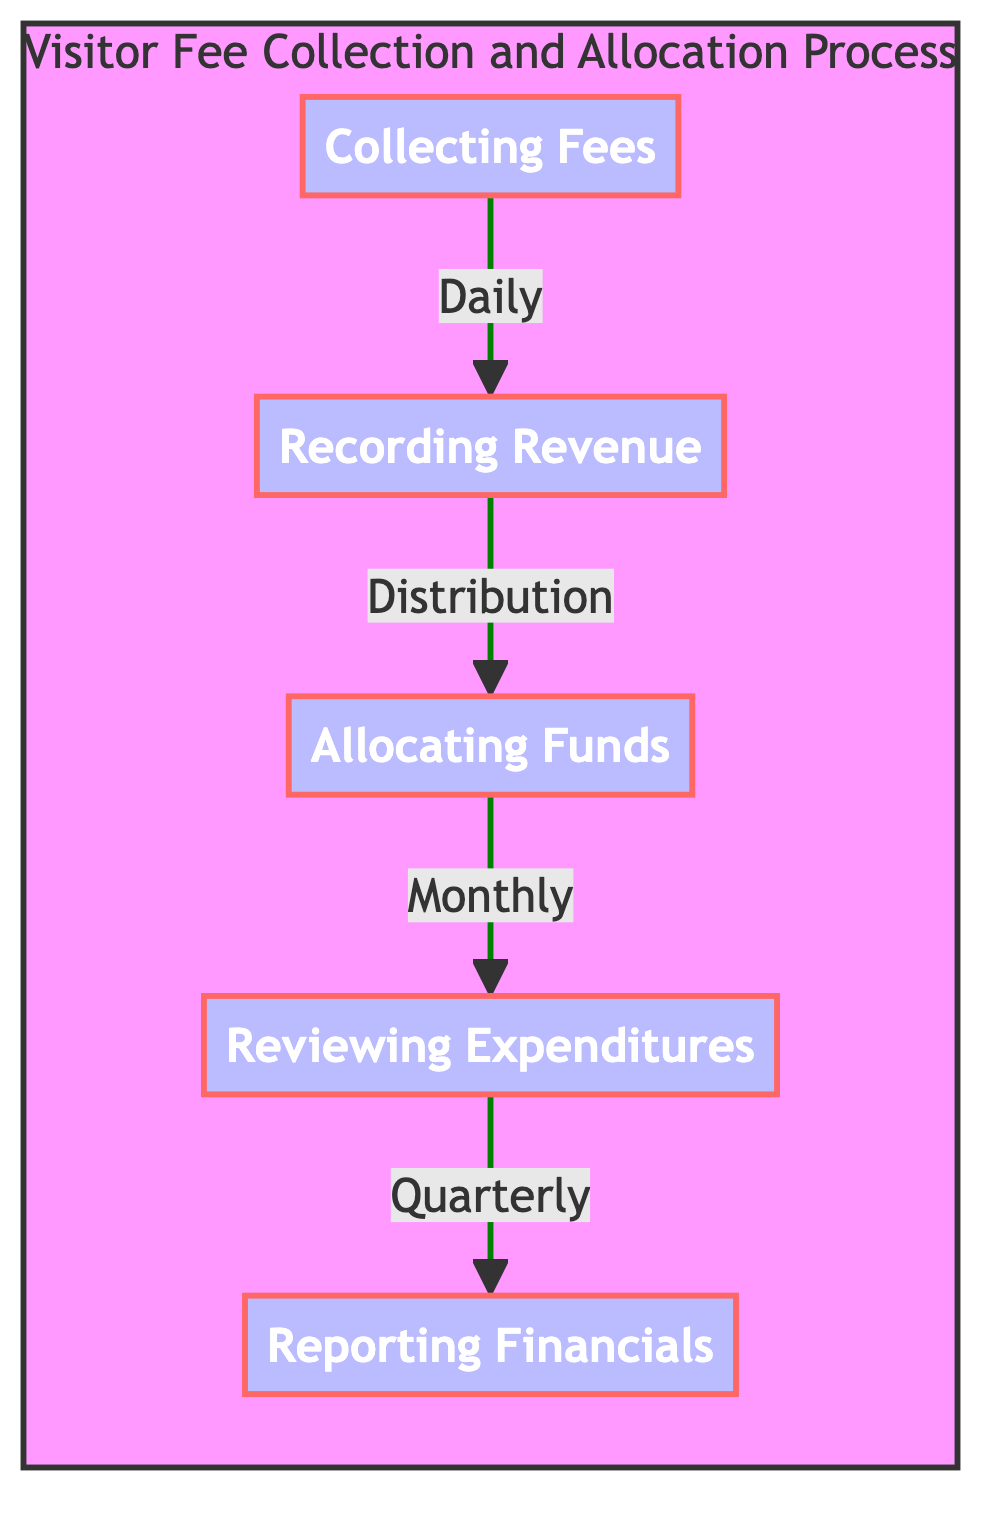What is the first step in the process? The diagram shows a flow starting from "Collecting Fees." This is the initial node and represents the beginning of the visitor fee collection and allocation process.
Answer: Collecting Fees How many steps are there in the process? The diagram lists five distinct steps: Collecting Fees, Recording Revenue, Allocating Funds, Reviewing Expenditures, and Reporting Financials. Counting these gives a total of five steps in the process.
Answer: Five What does "Recording Revenue" relate to? The flowchart has an arrow pointing from "Collecting Fees" to "Recording Revenue," indicating that revenue is recorded after fees are collected. This shows a direct relationship where each step depends on the previous one.
Answer: Collecting Fees Which step is performed monthly? According to the diagram, "Reviewing Expenditures" is indicated to take place on a monthly basis, following "Allocating Funds." This confirms the frequency of this step in the overall process.
Answer: Reviewing Expenditures What is prepared quarterly? "Reporting Financials" is noted as occurring quarterly in the flowchart, indicating it is the final step in the process where reports are prepared and submitted to the City Council.
Answer: Reporting Financials How does "Allocating Funds" connect to the previous step? The arrow direction from "Recording Revenue" to "Allocating Funds" indicates that funds are allocated only after revenue has been recorded, showing a dependence between these two steps in the process.
Answer: Recording Revenue What is the final step in the Visitor Fee process? The last step shown in the flowchart is "Reporting Financials," thus concluding the entire process of fee collection and fund allocation. This is evidenced by it being the last of the five steps.
Answer: Reporting Financials What type of document is generated in the last step? The final step "Reporting Financials" suggests financial reports are generated as a result, which are submitted to the City Council. This indicates the nature of the outcome of this step.
Answer: Financial reports What dictates the flow to the next step after "Recording Revenue"? The flow from "Recording Revenue" to "Allocating Funds" is indicated and labeled as distribution, meaning this action results in the movement of recorded revenue to the next logical step, highlighting its role in the process.
Answer: Distribution 